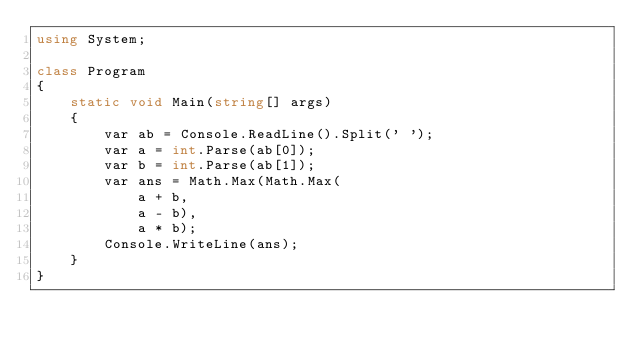Convert code to text. <code><loc_0><loc_0><loc_500><loc_500><_C#_>using System;

class Program
{
    static void Main(string[] args)
    {
        var ab = Console.ReadLine().Split(' ');
        var a = int.Parse(ab[0]);
        var b = int.Parse(ab[1]);
        var ans = Math.Max(Math.Max(
            a + b,
            a - b),
            a * b);
        Console.WriteLine(ans);
    }
}
</code> 